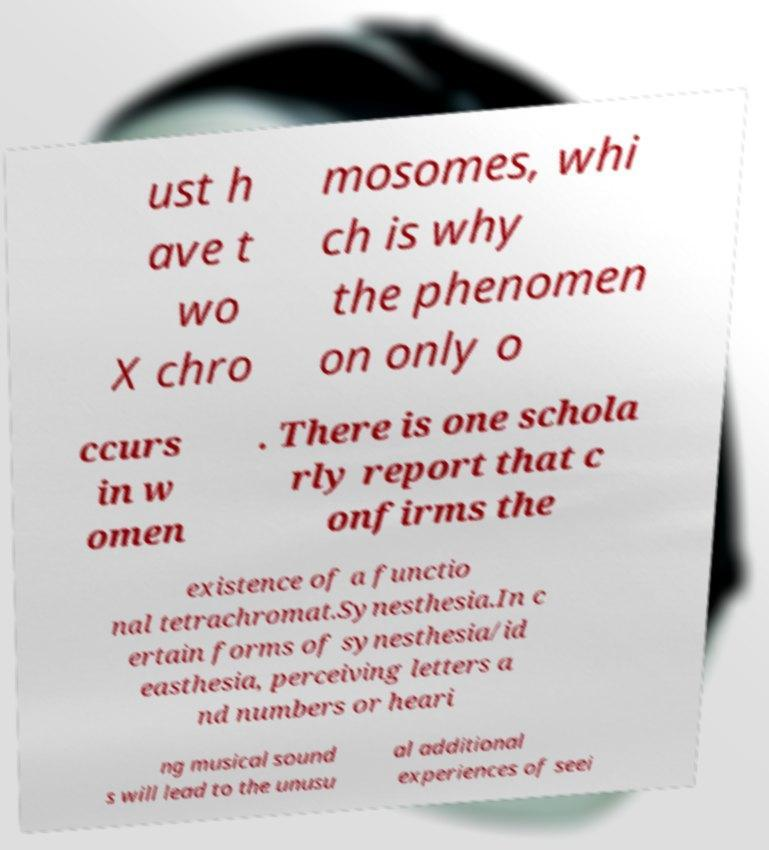Can you accurately transcribe the text from the provided image for me? ust h ave t wo X chro mosomes, whi ch is why the phenomen on only o ccurs in w omen . There is one schola rly report that c onfirms the existence of a functio nal tetrachromat.Synesthesia.In c ertain forms of synesthesia/id easthesia, perceiving letters a nd numbers or heari ng musical sound s will lead to the unusu al additional experiences of seei 